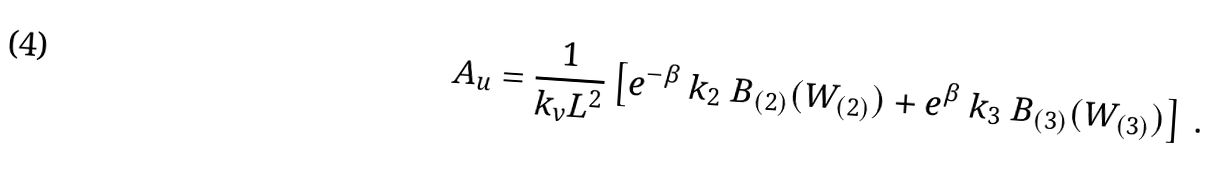Convert formula to latex. <formula><loc_0><loc_0><loc_500><loc_500>A _ { u } = \frac { 1 } { k _ { v } L ^ { 2 } } \left [ e ^ { - \beta } \ k _ { 2 } \ B _ { ( 2 ) } ( W _ { ( 2 ) } ) + e ^ { \beta } \ k _ { 3 } \ B _ { ( 3 ) } ( W _ { ( 3 ) } ) \right ] \, .</formula> 